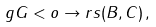<formula> <loc_0><loc_0><loc_500><loc_500>\ g G < o \to r s ( B , C ) \, ,</formula> 